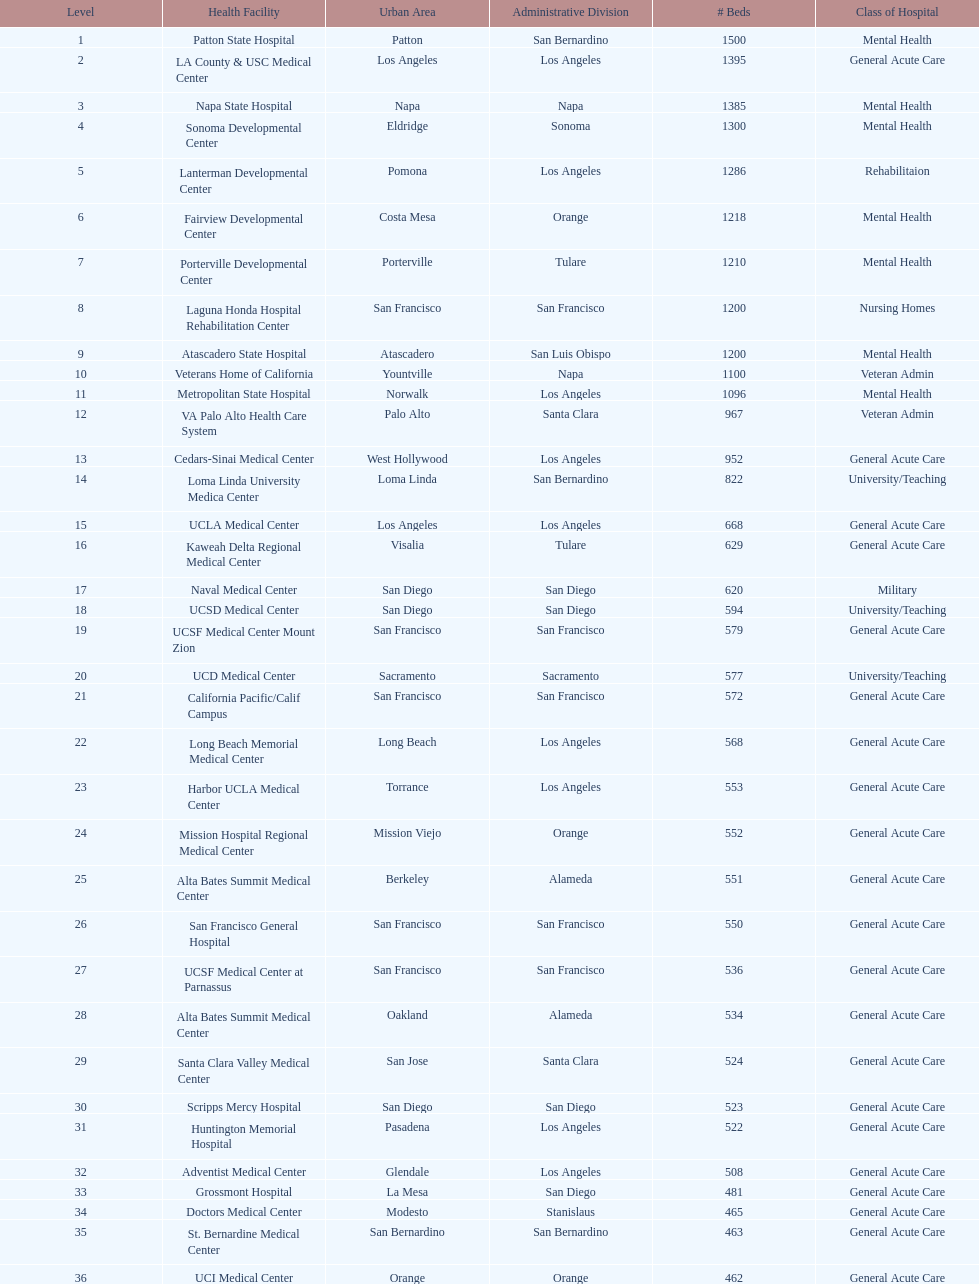Help me parse the entirety of this table. {'header': ['Level', 'Health Facility', 'Urban Area', 'Administrative Division', '# Beds', 'Class of Hospital'], 'rows': [['1', 'Patton State Hospital', 'Patton', 'San Bernardino', '1500', 'Mental Health'], ['2', 'LA County & USC Medical Center', 'Los Angeles', 'Los Angeles', '1395', 'General Acute Care'], ['3', 'Napa State Hospital', 'Napa', 'Napa', '1385', 'Mental Health'], ['4', 'Sonoma Developmental Center', 'Eldridge', 'Sonoma', '1300', 'Mental Health'], ['5', 'Lanterman Developmental Center', 'Pomona', 'Los Angeles', '1286', 'Rehabilitaion'], ['6', 'Fairview Developmental Center', 'Costa Mesa', 'Orange', '1218', 'Mental Health'], ['7', 'Porterville Developmental Center', 'Porterville', 'Tulare', '1210', 'Mental Health'], ['8', 'Laguna Honda Hospital Rehabilitation Center', 'San Francisco', 'San Francisco', '1200', 'Nursing Homes'], ['9', 'Atascadero State Hospital', 'Atascadero', 'San Luis Obispo', '1200', 'Mental Health'], ['10', 'Veterans Home of California', 'Yountville', 'Napa', '1100', 'Veteran Admin'], ['11', 'Metropolitan State Hospital', 'Norwalk', 'Los Angeles', '1096', 'Mental Health'], ['12', 'VA Palo Alto Health Care System', 'Palo Alto', 'Santa Clara', '967', 'Veteran Admin'], ['13', 'Cedars-Sinai Medical Center', 'West Hollywood', 'Los Angeles', '952', 'General Acute Care'], ['14', 'Loma Linda University Medica Center', 'Loma Linda', 'San Bernardino', '822', 'University/Teaching'], ['15', 'UCLA Medical Center', 'Los Angeles', 'Los Angeles', '668', 'General Acute Care'], ['16', 'Kaweah Delta Regional Medical Center', 'Visalia', 'Tulare', '629', 'General Acute Care'], ['17', 'Naval Medical Center', 'San Diego', 'San Diego', '620', 'Military'], ['18', 'UCSD Medical Center', 'San Diego', 'San Diego', '594', 'University/Teaching'], ['19', 'UCSF Medical Center Mount Zion', 'San Francisco', 'San Francisco', '579', 'General Acute Care'], ['20', 'UCD Medical Center', 'Sacramento', 'Sacramento', '577', 'University/Teaching'], ['21', 'California Pacific/Calif Campus', 'San Francisco', 'San Francisco', '572', 'General Acute Care'], ['22', 'Long Beach Memorial Medical Center', 'Long Beach', 'Los Angeles', '568', 'General Acute Care'], ['23', 'Harbor UCLA Medical Center', 'Torrance', 'Los Angeles', '553', 'General Acute Care'], ['24', 'Mission Hospital Regional Medical Center', 'Mission Viejo', 'Orange', '552', 'General Acute Care'], ['25', 'Alta Bates Summit Medical Center', 'Berkeley', 'Alameda', '551', 'General Acute Care'], ['26', 'San Francisco General Hospital', 'San Francisco', 'San Francisco', '550', 'General Acute Care'], ['27', 'UCSF Medical Center at Parnassus', 'San Francisco', 'San Francisco', '536', 'General Acute Care'], ['28', 'Alta Bates Summit Medical Center', 'Oakland', 'Alameda', '534', 'General Acute Care'], ['29', 'Santa Clara Valley Medical Center', 'San Jose', 'Santa Clara', '524', 'General Acute Care'], ['30', 'Scripps Mercy Hospital', 'San Diego', 'San Diego', '523', 'General Acute Care'], ['31', 'Huntington Memorial Hospital', 'Pasadena', 'Los Angeles', '522', 'General Acute Care'], ['32', 'Adventist Medical Center', 'Glendale', 'Los Angeles', '508', 'General Acute Care'], ['33', 'Grossmont Hospital', 'La Mesa', 'San Diego', '481', 'General Acute Care'], ['34', 'Doctors Medical Center', 'Modesto', 'Stanislaus', '465', 'General Acute Care'], ['35', 'St. Bernardine Medical Center', 'San Bernardino', 'San Bernardino', '463', 'General Acute Care'], ['36', 'UCI Medical Center', 'Orange', 'Orange', '462', 'General Acute Care'], ['37', 'Stanford Medical Center', 'Stanford', 'Santa Clara', '460', 'General Acute Care'], ['38', 'Community Regional Medical Center', 'Fresno', 'Fresno', '457', 'General Acute Care'], ['39', 'Methodist Hospital', 'Arcadia', 'Los Angeles', '455', 'General Acute Care'], ['40', 'Providence St. Joseph Medical Center', 'Burbank', 'Los Angeles', '455', 'General Acute Care'], ['41', 'Hoag Memorial Hospital', 'Newport Beach', 'Orange', '450', 'General Acute Care'], ['42', 'Agnews Developmental Center', 'San Jose', 'Santa Clara', '450', 'Mental Health'], ['43', 'Jewish Home', 'San Francisco', 'San Francisco', '450', 'Nursing Homes'], ['44', 'St. Joseph Hospital Orange', 'Orange', 'Orange', '448', 'General Acute Care'], ['45', 'Presbyterian Intercommunity', 'Whittier', 'Los Angeles', '441', 'General Acute Care'], ['46', 'Kaiser Permanente Medical Center', 'Fontana', 'San Bernardino', '440', 'General Acute Care'], ['47', 'Kaiser Permanente Medical Center', 'Los Angeles', 'Los Angeles', '439', 'General Acute Care'], ['48', 'Pomona Valley Hospital Medical Center', 'Pomona', 'Los Angeles', '436', 'General Acute Care'], ['49', 'Sutter General Medical Center', 'Sacramento', 'Sacramento', '432', 'General Acute Care'], ['50', 'St. Mary Medical Center', 'San Francisco', 'San Francisco', '430', 'General Acute Care'], ['50', 'Good Samaritan Hospital', 'San Jose', 'Santa Clara', '429', 'General Acute Care']]} How many additional general acute care hospitals are present in california compared to rehabilitation hospitals? 33. 